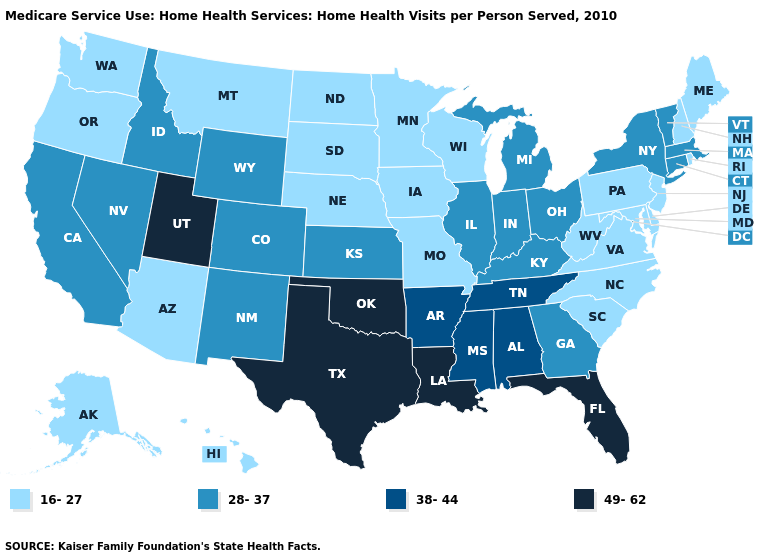Does Florida have the highest value in the USA?
Short answer required. Yes. Does Colorado have the highest value in the USA?
Quick response, please. No. How many symbols are there in the legend?
Give a very brief answer. 4. What is the lowest value in states that border Texas?
Concise answer only. 28-37. Which states have the lowest value in the USA?
Write a very short answer. Alaska, Arizona, Delaware, Hawaii, Iowa, Maine, Maryland, Minnesota, Missouri, Montana, Nebraska, New Hampshire, New Jersey, North Carolina, North Dakota, Oregon, Pennsylvania, Rhode Island, South Carolina, South Dakota, Virginia, Washington, West Virginia, Wisconsin. What is the lowest value in the West?
Short answer required. 16-27. Does the first symbol in the legend represent the smallest category?
Short answer required. Yes. What is the value of Illinois?
Keep it brief. 28-37. Name the states that have a value in the range 16-27?
Keep it brief. Alaska, Arizona, Delaware, Hawaii, Iowa, Maine, Maryland, Minnesota, Missouri, Montana, Nebraska, New Hampshire, New Jersey, North Carolina, North Dakota, Oregon, Pennsylvania, Rhode Island, South Carolina, South Dakota, Virginia, Washington, West Virginia, Wisconsin. Among the states that border Florida , which have the highest value?
Quick response, please. Alabama. What is the lowest value in the USA?
Concise answer only. 16-27. Which states have the lowest value in the West?
Give a very brief answer. Alaska, Arizona, Hawaii, Montana, Oregon, Washington. Does Arkansas have the highest value in the South?
Short answer required. No. What is the value of Ohio?
Short answer required. 28-37. Does South Dakota have a higher value than Maryland?
Answer briefly. No. 